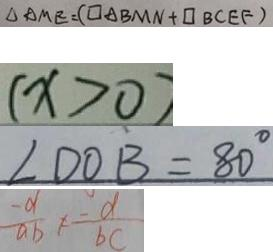<formula> <loc_0><loc_0><loc_500><loc_500>\Delta A M E = ( \square A B M N + \square B C E F ) 
 ( x > 0 ) 
 \angle D O B = 8 0 ^ { \circ } 
 \frac { - a } { a b } \neq \frac { - d } { b c }</formula> 